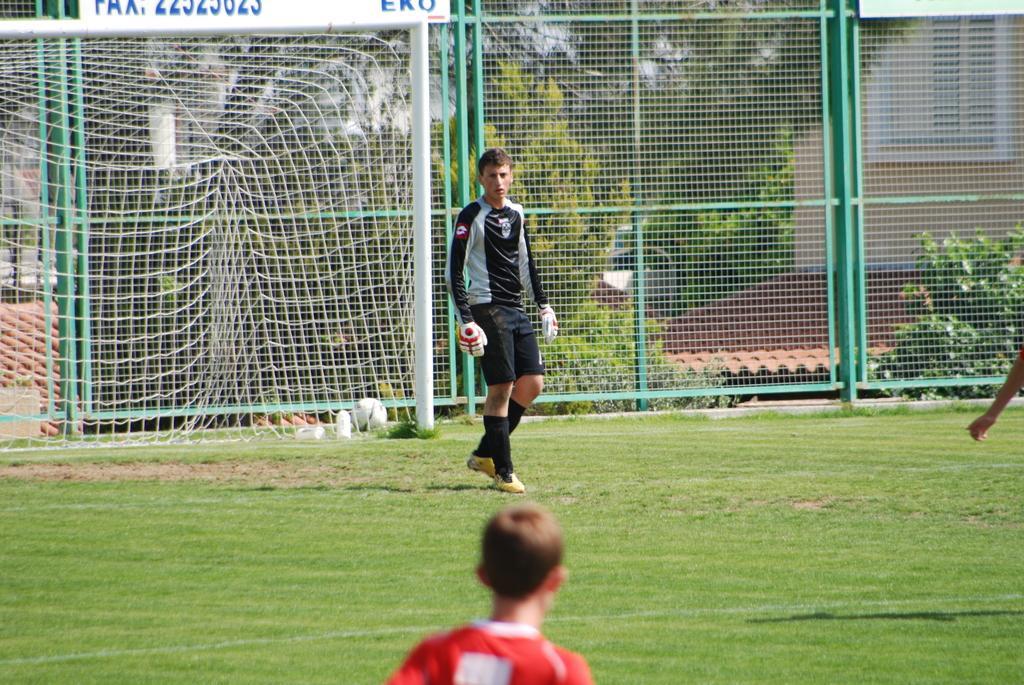Describe this image in one or two sentences. In this image I can see the ground, some grass on the ground and few persons are standing on the ground. In the background I can see the metal fencing, a soccer goal post, few trees and few buildings. 